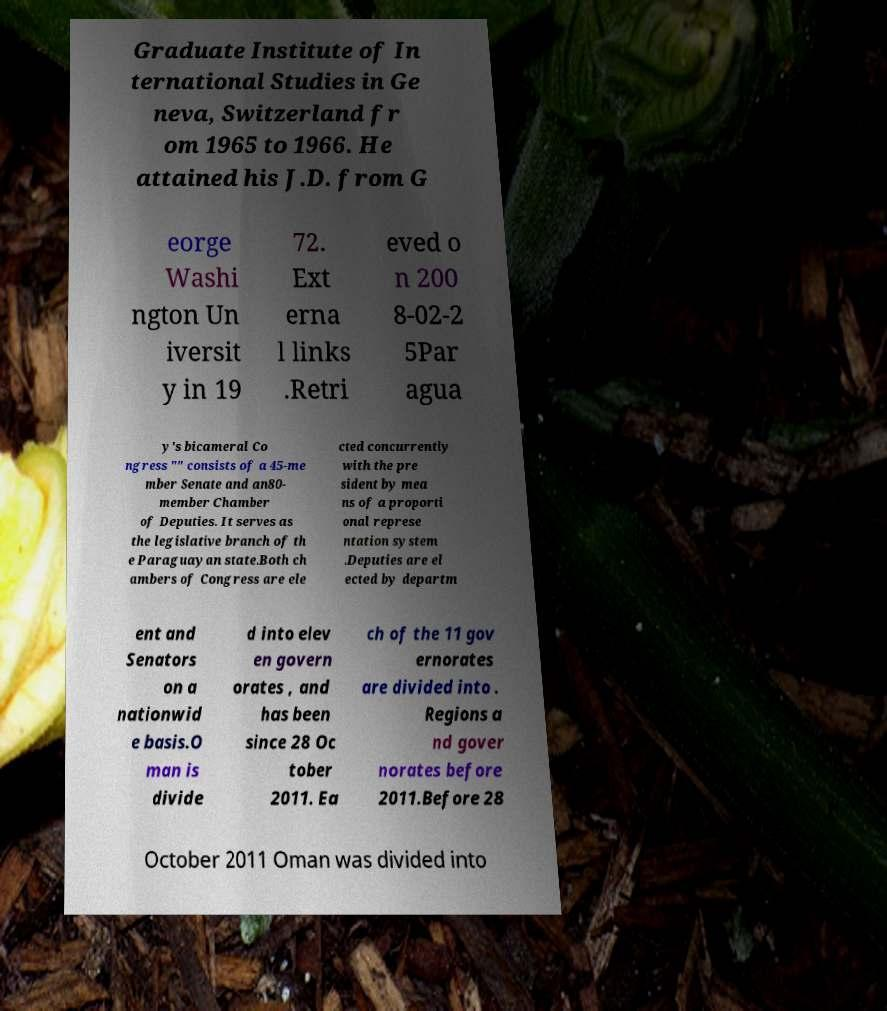There's text embedded in this image that I need extracted. Can you transcribe it verbatim? Graduate Institute of In ternational Studies in Ge neva, Switzerland fr om 1965 to 1966. He attained his J.D. from G eorge Washi ngton Un iversit y in 19 72. Ext erna l links .Retri eved o n 200 8-02-2 5Par agua y's bicameral Co ngress "" consists of a 45-me mber Senate and an80- member Chamber of Deputies. It serves as the legislative branch of th e Paraguayan state.Both ch ambers of Congress are ele cted concurrently with the pre sident by mea ns of a proporti onal represe ntation system .Deputies are el ected by departm ent and Senators on a nationwid e basis.O man is divide d into elev en govern orates , and has been since 28 Oc tober 2011. Ea ch of the 11 gov ernorates are divided into . Regions a nd gover norates before 2011.Before 28 October 2011 Oman was divided into 